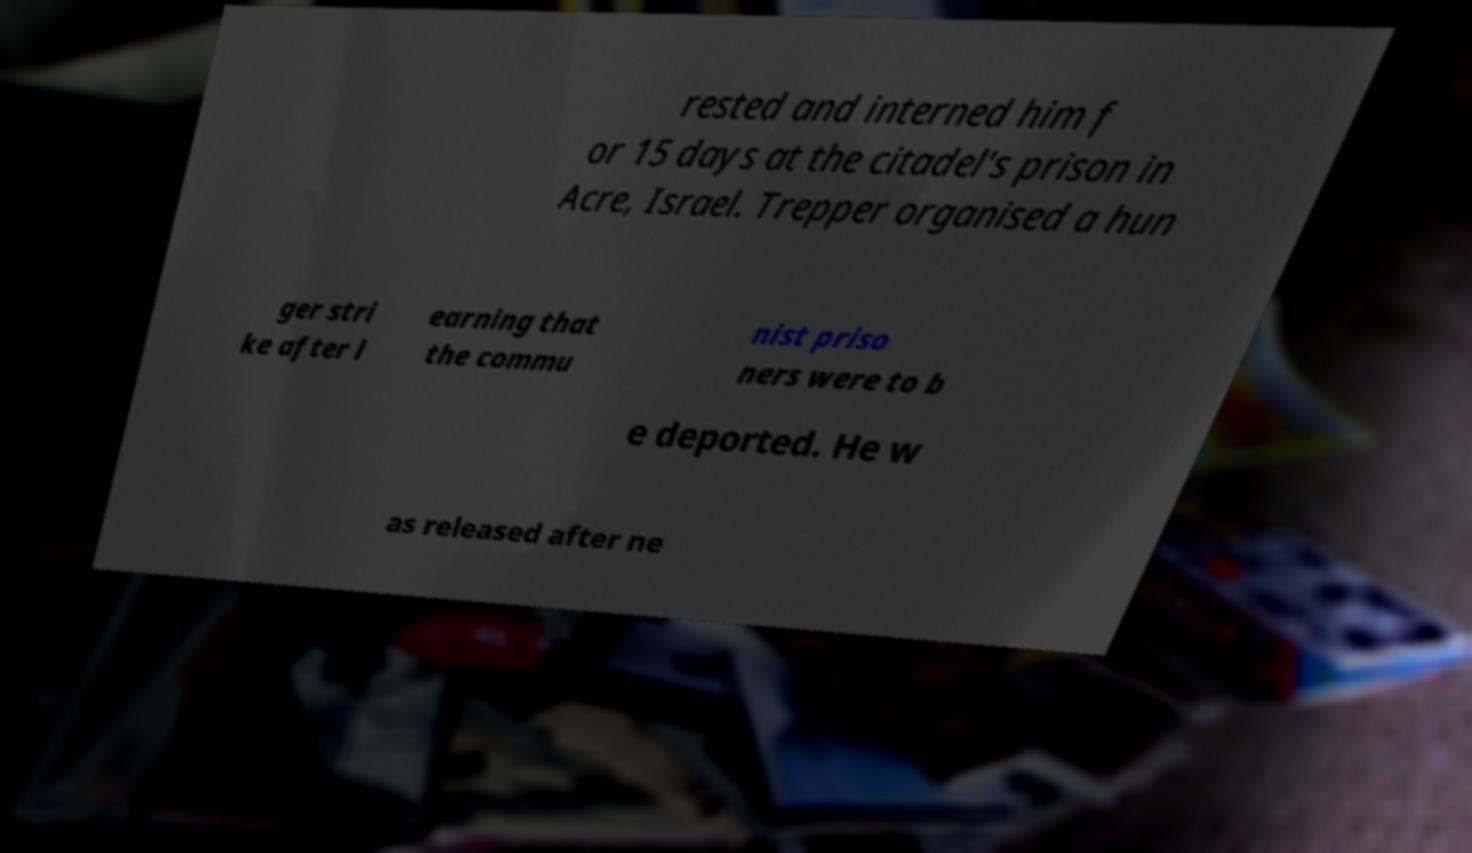Can you read and provide the text displayed in the image?This photo seems to have some interesting text. Can you extract and type it out for me? rested and interned him f or 15 days at the citadel's prison in Acre, Israel. Trepper organised a hun ger stri ke after l earning that the commu nist priso ners were to b e deported. He w as released after ne 